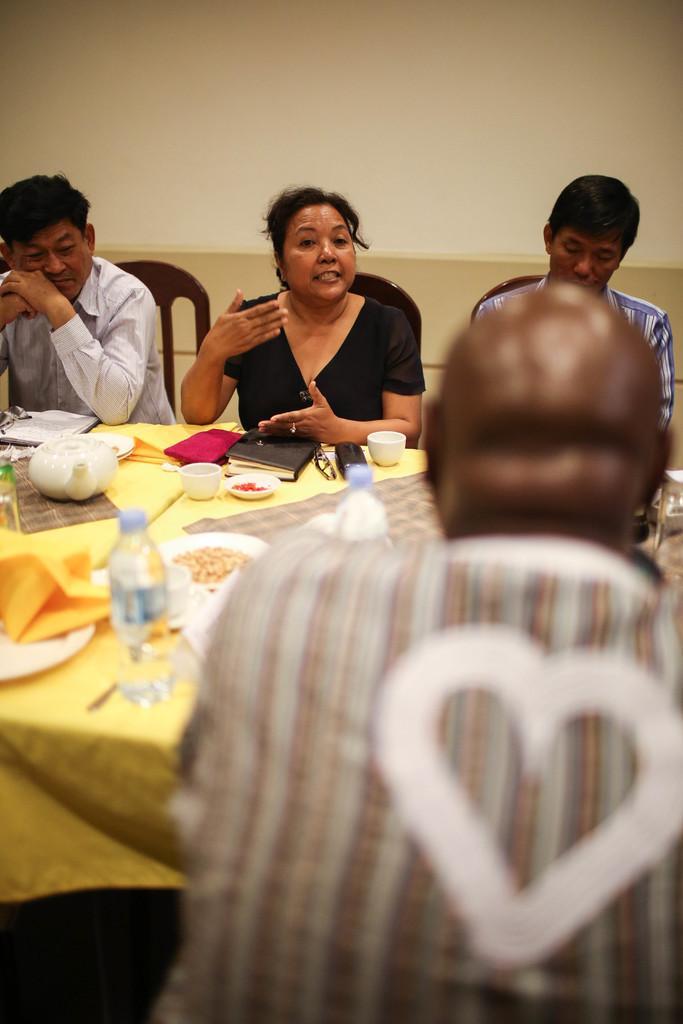Could you give a brief overview of what you see in this image? There are a four people who are sitting on a chair and the person in the middle is talking to this person. This is a table where a glass bottle, a book, a cup and a tea jar are kept on it. 